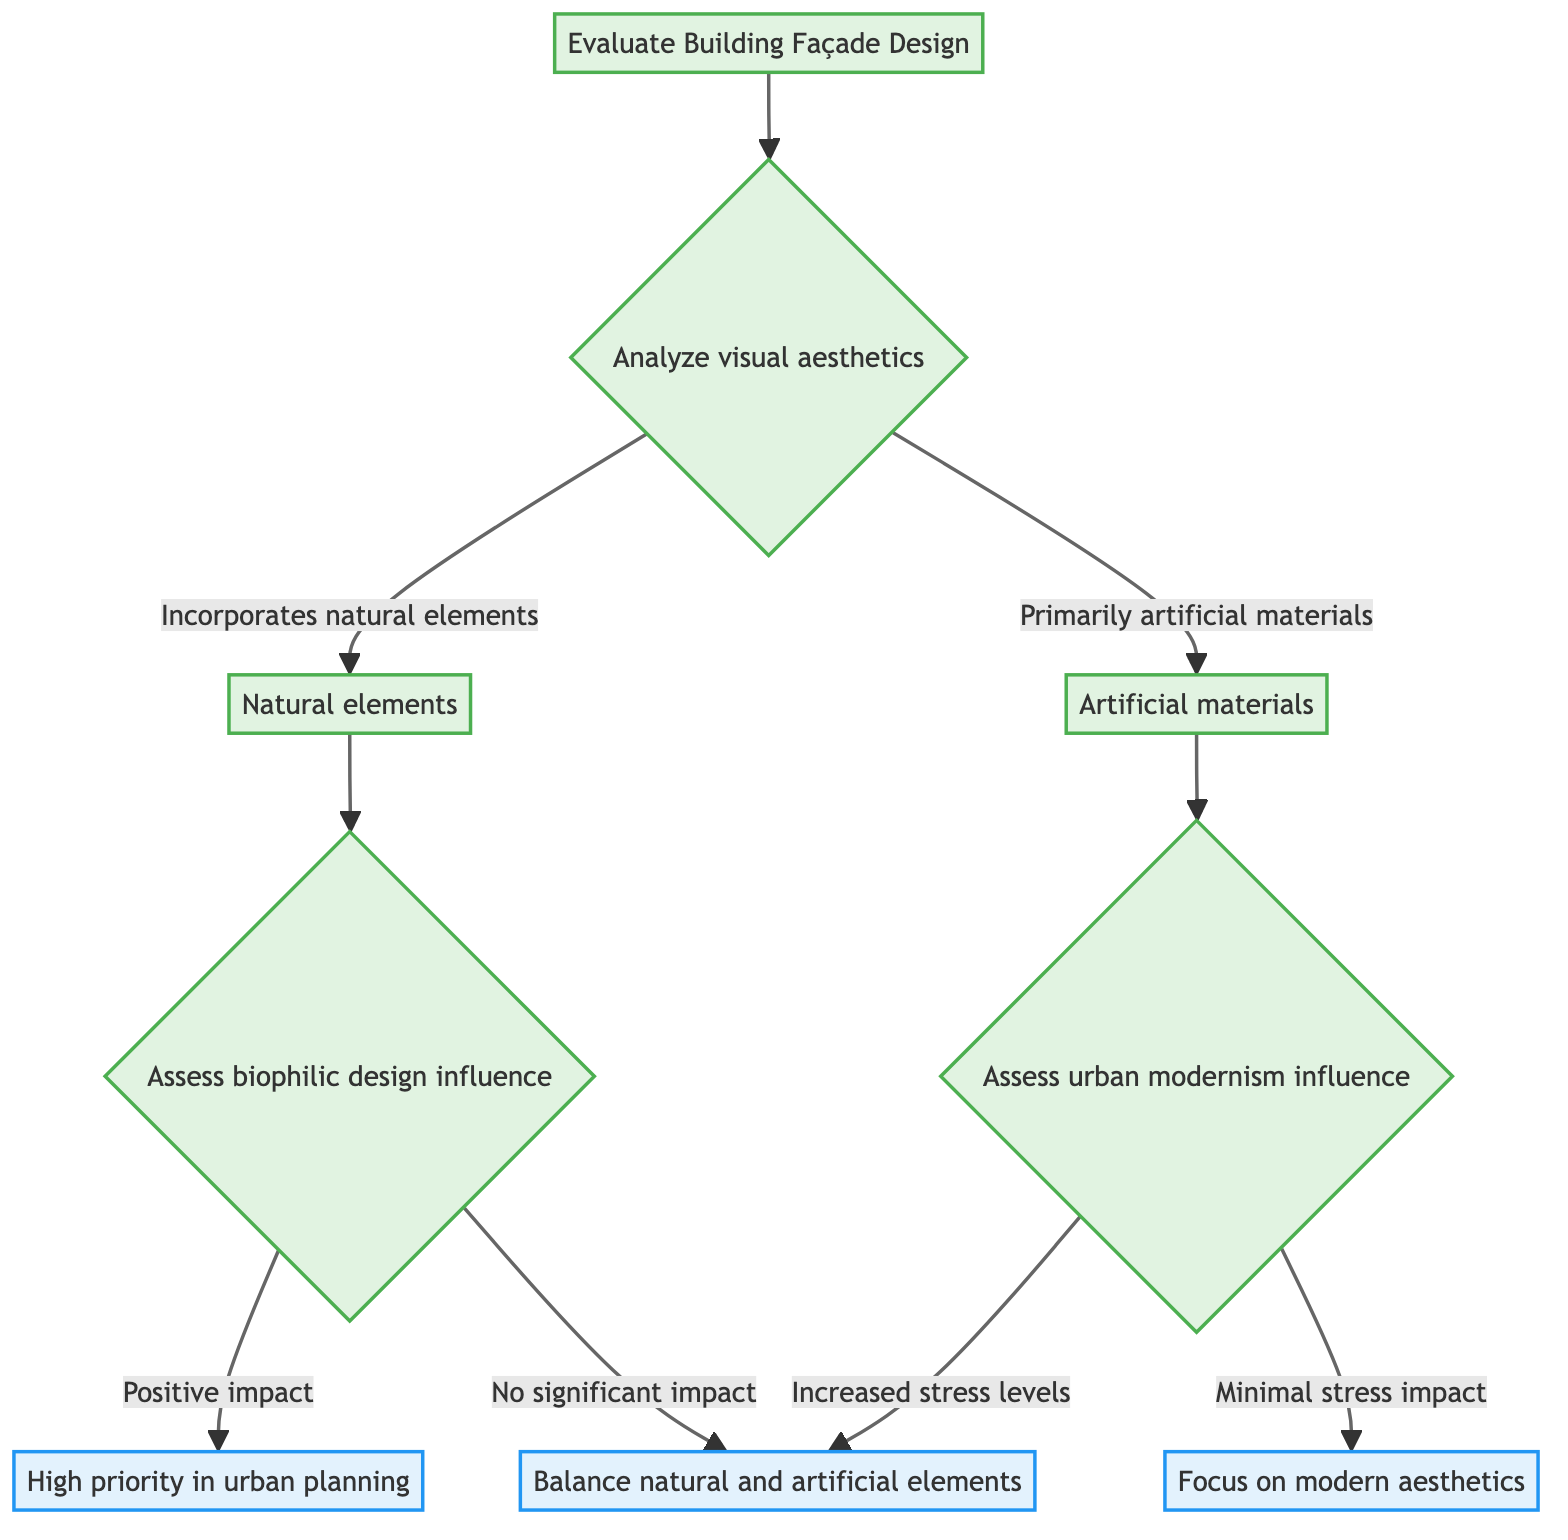What is the starting point of the decision tree? The decision tree starts with the node labeled "Evaluate Building Façade Design."
Answer: Evaluate Building Façade Design How many choices does "Analyze visual aesthetics" have? The node "Analyze visual aesthetics" has two choices: "Incorporates natural elements" and "Primarily artificial materials," totaling two choices.
Answer: Two choices What happens if the design incorporates natural elements? If the design incorporates natural elements, the next step assesses biophilic design influence.
Answer: Assess biophilic design influence What is the outcome if there is a positive impact on stress reduction? If there is a positive impact on stress reduction, the outcome is "High priority in urban planning."
Answer: High priority in urban planning What choice do you make if the assessment of urban modernism shows increased stress levels? If the assessment of urban modernism shows increased stress levels, the decision is to "Balance natural and artificial elements."
Answer: Balance natural and artificial elements What are the two options following the assessment of artificial materials? Following the assessment of artificial materials, the two options are "Increased stress levels" and "Minimal stress impact."
Answer: Increased stress levels and Minimal stress impact If natural elements have no significant impact, what is the next step? If natural elements have no significant impact, the next step is to decide on the use of materials, leading to a specific decision.
Answer: Decision on use of materials What is the relationship between "Positive impact on stress reduction" and "High priority in urban planning"? "Positive impact on stress reduction" leads directly to the outcome "High priority in urban planning," indicating a direct progression.
Answer: Direct progression 